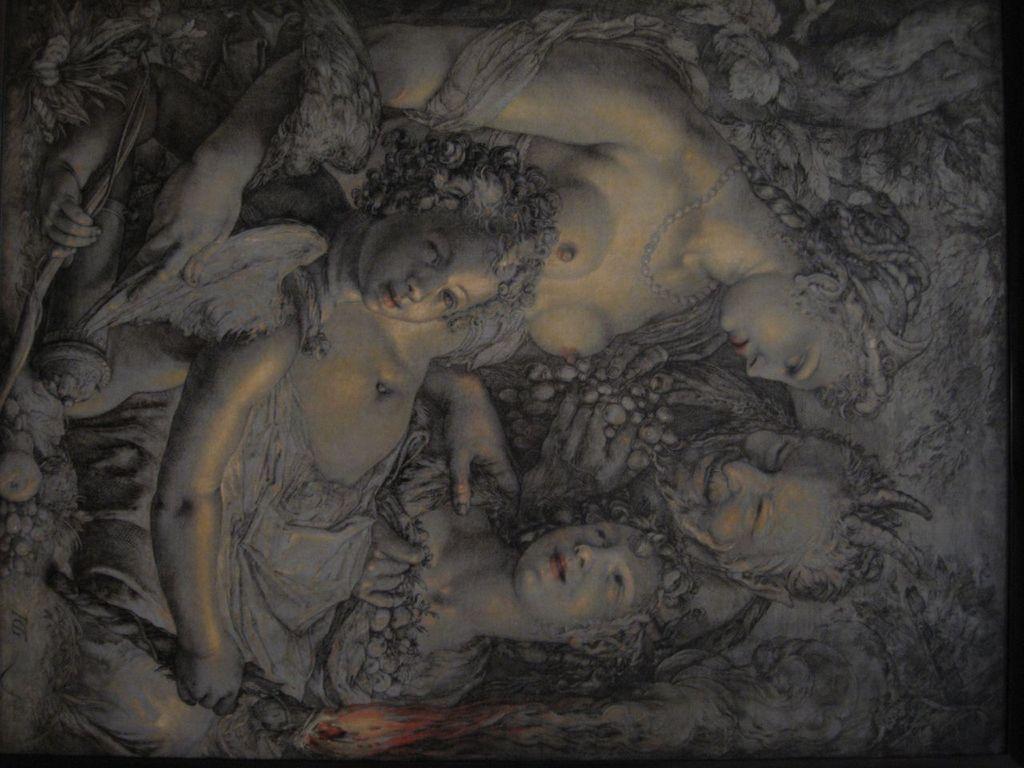Describe this image in one or two sentences. In this image there is a painting of four persons, there is a person holding an object, there is the fire, there are leaves. 